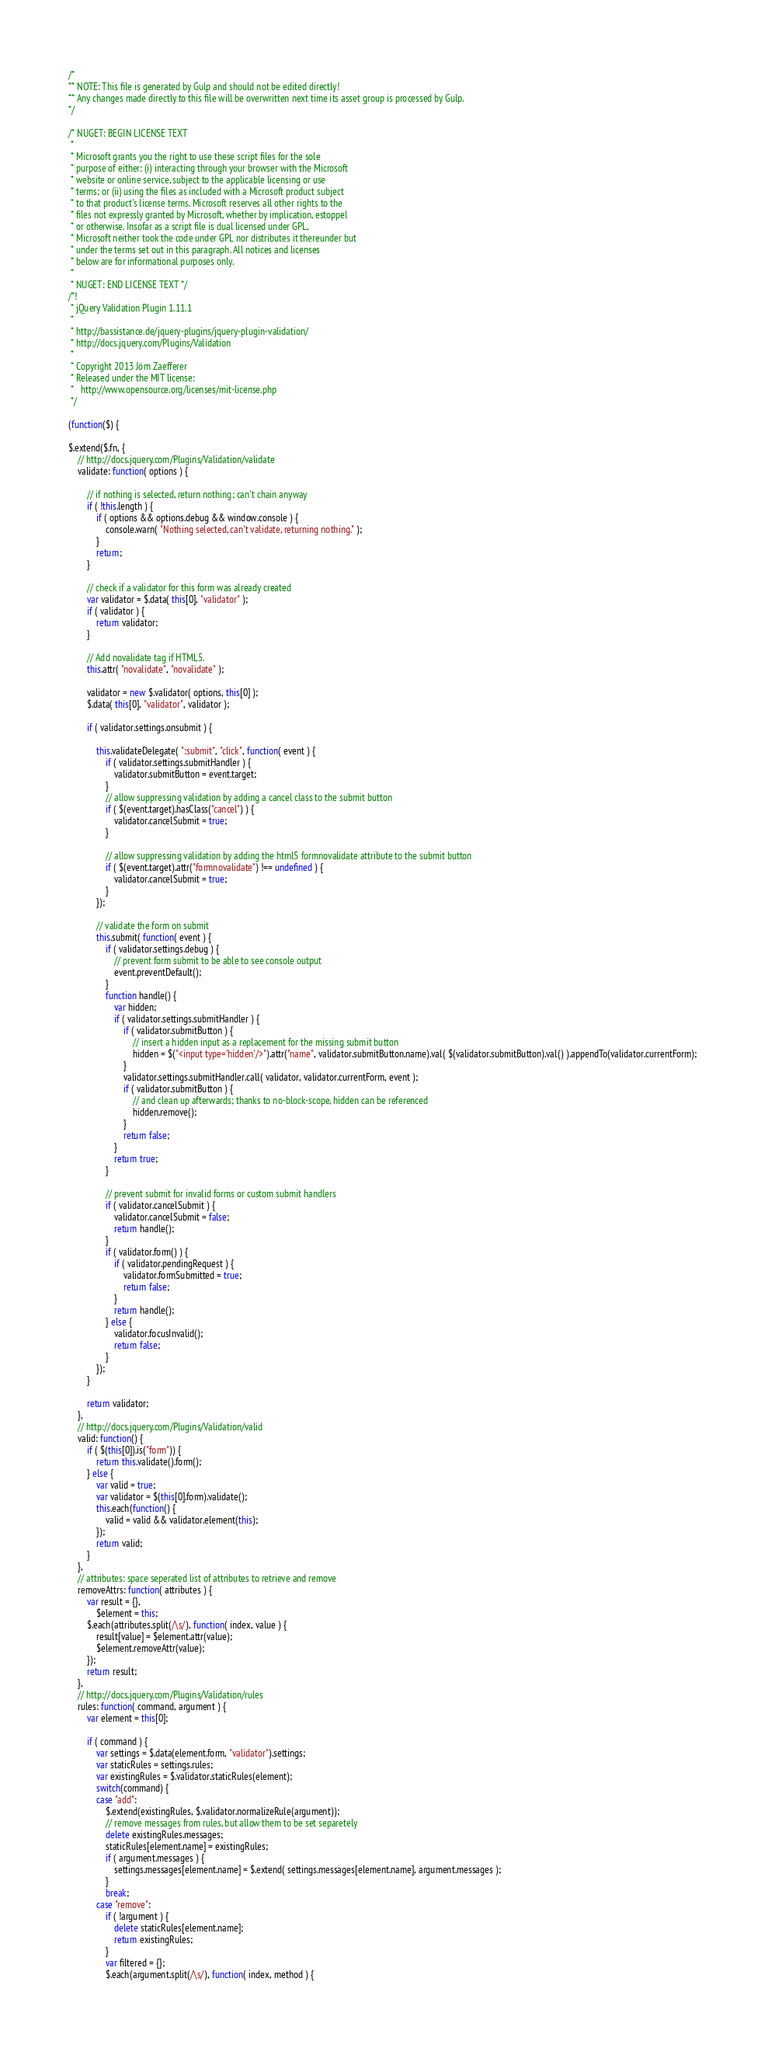Convert code to text. <code><loc_0><loc_0><loc_500><loc_500><_JavaScript_>/*
** NOTE: This file is generated by Gulp and should not be edited directly!
** Any changes made directly to this file will be overwritten next time its asset group is processed by Gulp.
*/

/* NUGET: BEGIN LICENSE TEXT
 *
 * Microsoft grants you the right to use these script files for the sole
 * purpose of either: (i) interacting through your browser with the Microsoft
 * website or online service, subject to the applicable licensing or use
 * terms; or (ii) using the files as included with a Microsoft product subject
 * to that product's license terms. Microsoft reserves all other rights to the
 * files not expressly granted by Microsoft, whether by implication, estoppel
 * or otherwise. Insofar as a script file is dual licensed under GPL,
 * Microsoft neither took the code under GPL nor distributes it thereunder but
 * under the terms set out in this paragraph. All notices and licenses
 * below are for informational purposes only.
 *
 * NUGET: END LICENSE TEXT */
/*!
 * jQuery Validation Plugin 1.11.1
 *
 * http://bassistance.de/jquery-plugins/jquery-plugin-validation/
 * http://docs.jquery.com/Plugins/Validation
 *
 * Copyright 2013 Jörn Zaefferer
 * Released under the MIT license:
 *   http://www.opensource.org/licenses/mit-license.php
 */

(function($) {

$.extend($.fn, {
	// http://docs.jquery.com/Plugins/Validation/validate
	validate: function( options ) {

		// if nothing is selected, return nothing; can't chain anyway
		if ( !this.length ) {
			if ( options && options.debug && window.console ) {
				console.warn( "Nothing selected, can't validate, returning nothing." );
			}
			return;
		}

		// check if a validator for this form was already created
		var validator = $.data( this[0], "validator" );
		if ( validator ) {
			return validator;
		}

		// Add novalidate tag if HTML5.
		this.attr( "novalidate", "novalidate" );

		validator = new $.validator( options, this[0] );
		$.data( this[0], "validator", validator );

		if ( validator.settings.onsubmit ) {

			this.validateDelegate( ":submit", "click", function( event ) {
				if ( validator.settings.submitHandler ) {
					validator.submitButton = event.target;
				}
				// allow suppressing validation by adding a cancel class to the submit button
				if ( $(event.target).hasClass("cancel") ) {
					validator.cancelSubmit = true;
				}

				// allow suppressing validation by adding the html5 formnovalidate attribute to the submit button
				if ( $(event.target).attr("formnovalidate") !== undefined ) {
					validator.cancelSubmit = true;
				}
			});

			// validate the form on submit
			this.submit( function( event ) {
				if ( validator.settings.debug ) {
					// prevent form submit to be able to see console output
					event.preventDefault();
				}
				function handle() {
					var hidden;
					if ( validator.settings.submitHandler ) {
						if ( validator.submitButton ) {
							// insert a hidden input as a replacement for the missing submit button
							hidden = $("<input type='hidden'/>").attr("name", validator.submitButton.name).val( $(validator.submitButton).val() ).appendTo(validator.currentForm);
						}
						validator.settings.submitHandler.call( validator, validator.currentForm, event );
						if ( validator.submitButton ) {
							// and clean up afterwards; thanks to no-block-scope, hidden can be referenced
							hidden.remove();
						}
						return false;
					}
					return true;
				}

				// prevent submit for invalid forms or custom submit handlers
				if ( validator.cancelSubmit ) {
					validator.cancelSubmit = false;
					return handle();
				}
				if ( validator.form() ) {
					if ( validator.pendingRequest ) {
						validator.formSubmitted = true;
						return false;
					}
					return handle();
				} else {
					validator.focusInvalid();
					return false;
				}
			});
		}

		return validator;
	},
	// http://docs.jquery.com/Plugins/Validation/valid
	valid: function() {
		if ( $(this[0]).is("form")) {
			return this.validate().form();
		} else {
			var valid = true;
			var validator = $(this[0].form).validate();
			this.each(function() {
				valid = valid && validator.element(this);
			});
			return valid;
		}
	},
	// attributes: space seperated list of attributes to retrieve and remove
	removeAttrs: function( attributes ) {
		var result = {},
			$element = this;
		$.each(attributes.split(/\s/), function( index, value ) {
			result[value] = $element.attr(value);
			$element.removeAttr(value);
		});
		return result;
	},
	// http://docs.jquery.com/Plugins/Validation/rules
	rules: function( command, argument ) {
		var element = this[0];

		if ( command ) {
			var settings = $.data(element.form, "validator").settings;
			var staticRules = settings.rules;
			var existingRules = $.validator.staticRules(element);
			switch(command) {
			case "add":
				$.extend(existingRules, $.validator.normalizeRule(argument));
				// remove messages from rules, but allow them to be set separetely
				delete existingRules.messages;
				staticRules[element.name] = existingRules;
				if ( argument.messages ) {
					settings.messages[element.name] = $.extend( settings.messages[element.name], argument.messages );
				}
				break;
			case "remove":
				if ( !argument ) {
					delete staticRules[element.name];
					return existingRules;
				}
				var filtered = {};
				$.each(argument.split(/\s/), function( index, method ) {</code> 